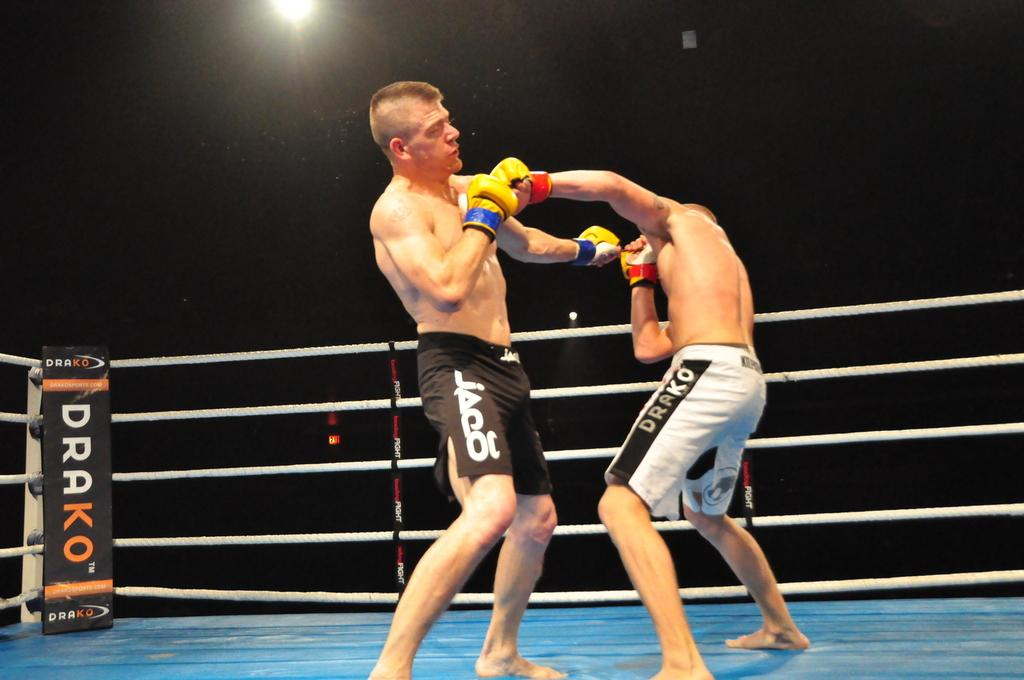Provide a one-sentence caption for the provided image. A man in white trunks with Drako on the side boxes with another man. 